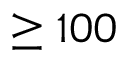<formula> <loc_0><loc_0><loc_500><loc_500>\geq 1 0 0</formula> 